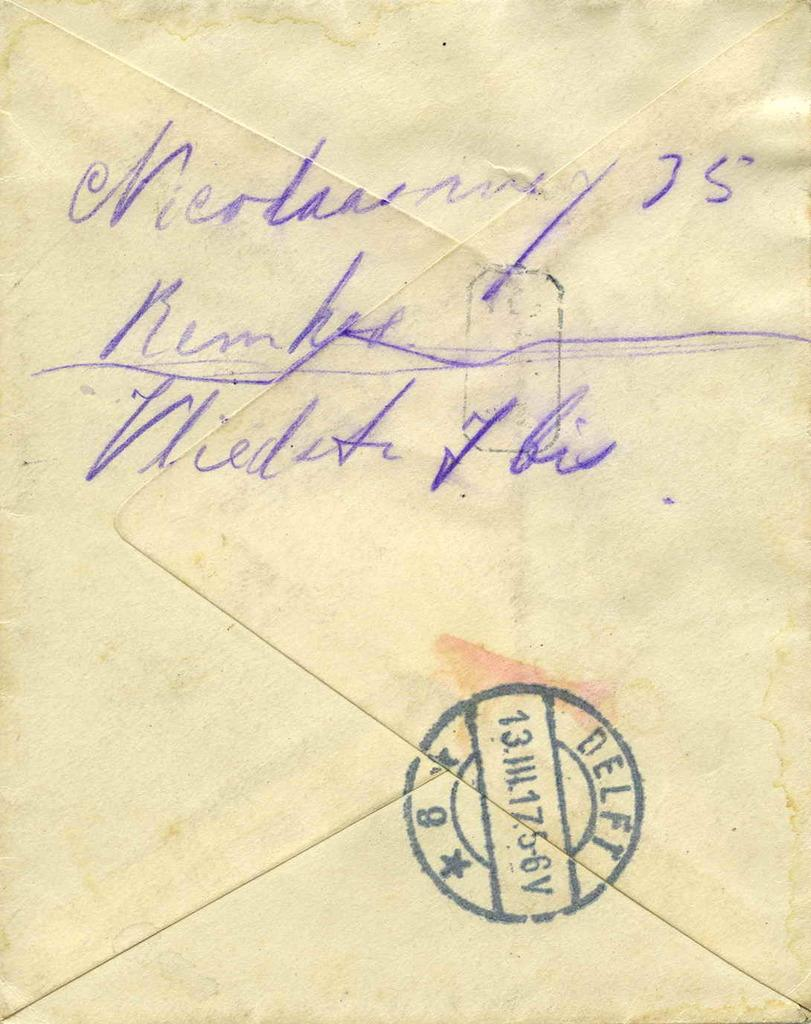Provide a one-sentence caption for the provided image. A really old envelope with hand writing on the back. 